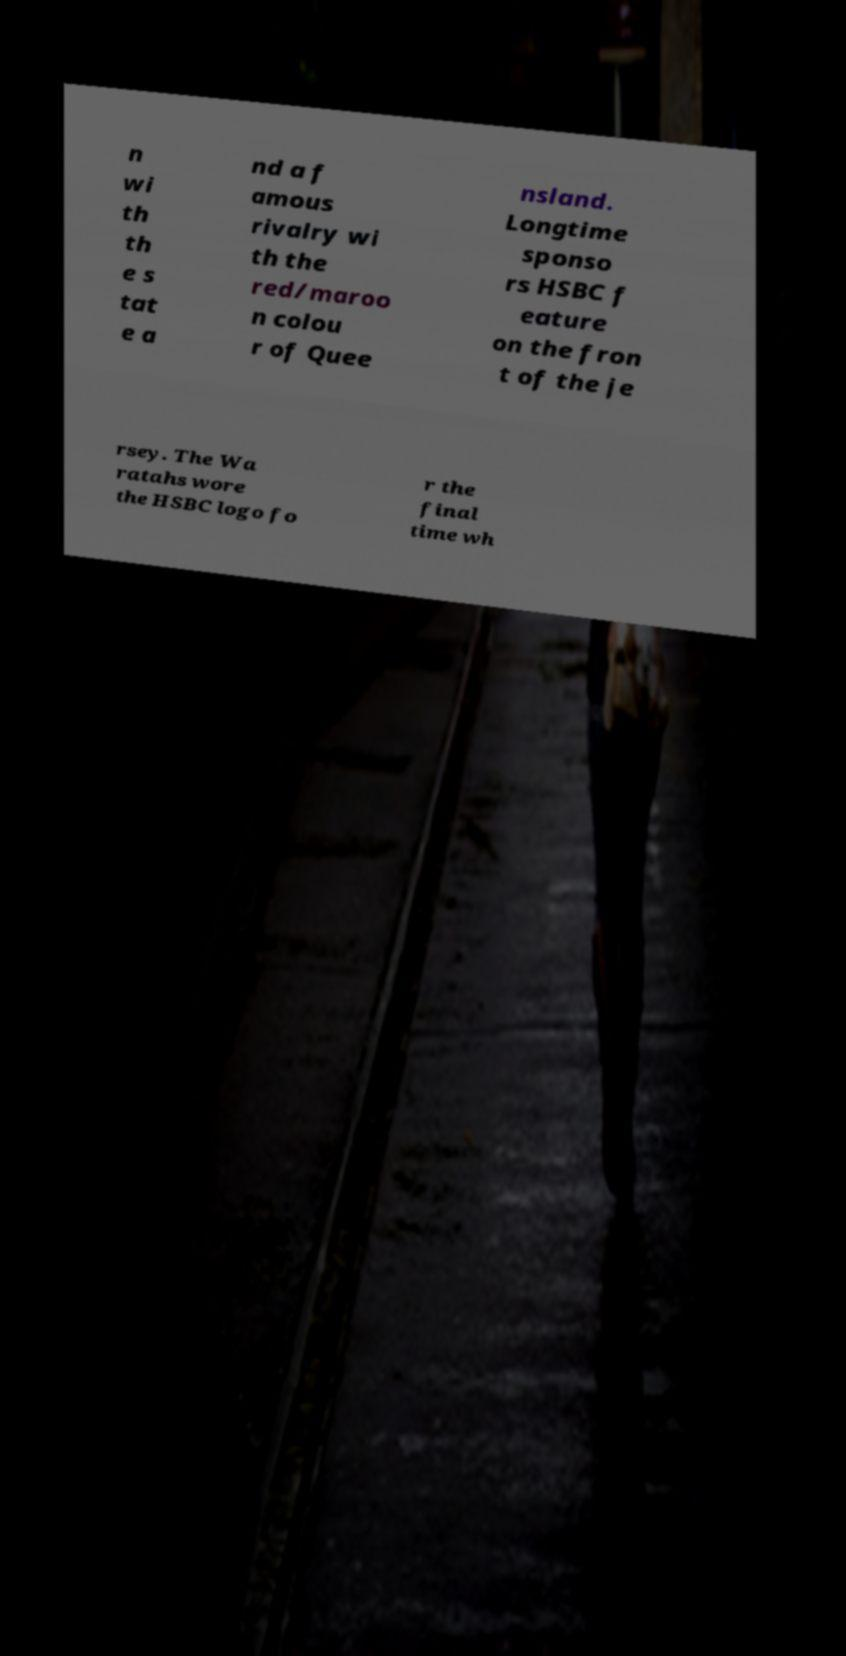Please identify and transcribe the text found in this image. n wi th th e s tat e a nd a f amous rivalry wi th the red/maroo n colou r of Quee nsland. Longtime sponso rs HSBC f eature on the fron t of the je rsey. The Wa ratahs wore the HSBC logo fo r the final time wh 